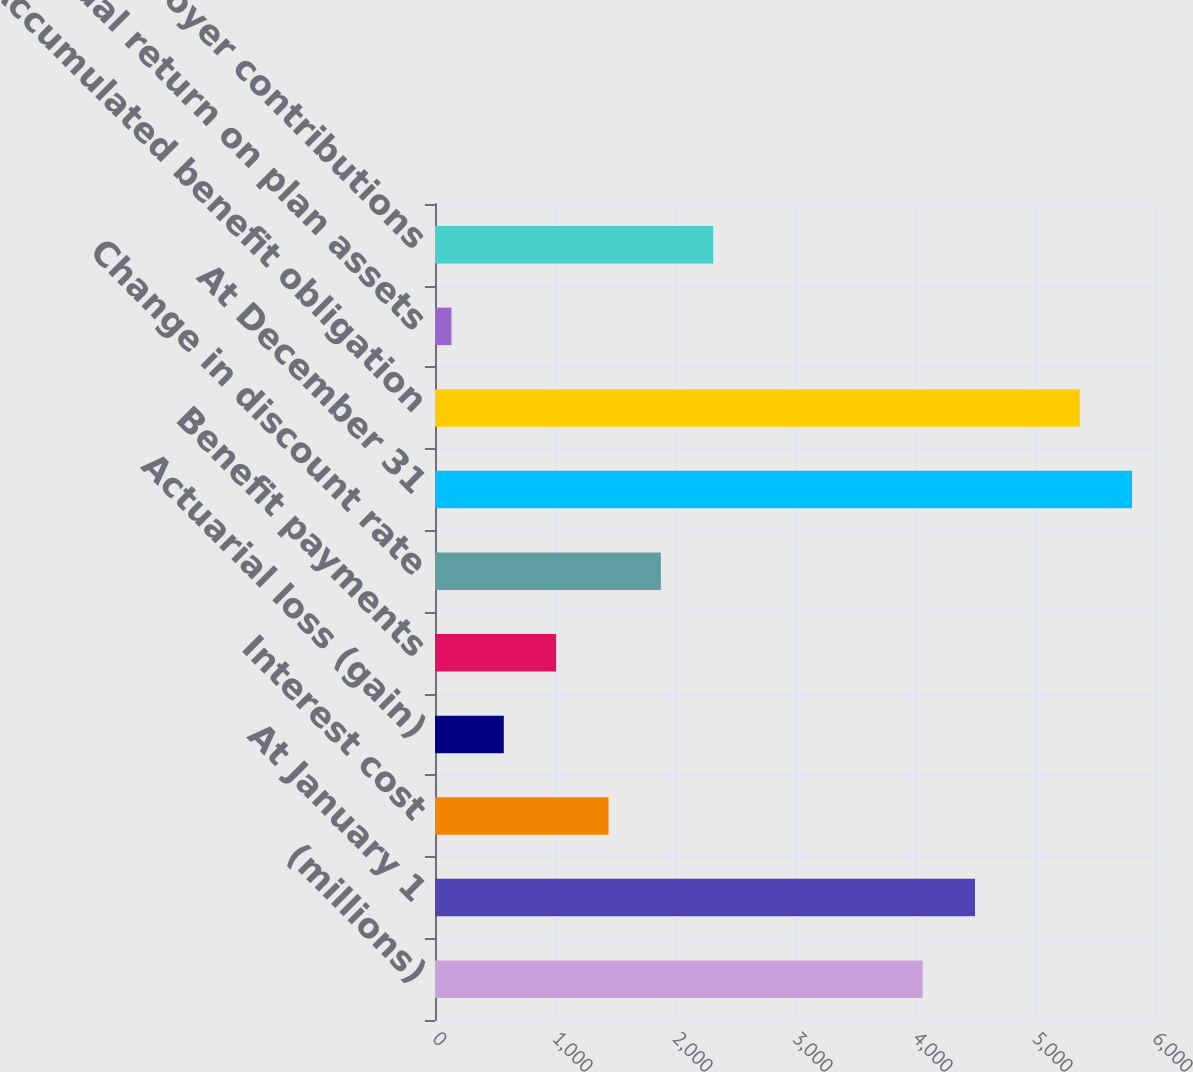<chart> <loc_0><loc_0><loc_500><loc_500><bar_chart><fcel>(millions)<fcel>At January 1<fcel>Interest cost<fcel>Actuarial loss (gain)<fcel>Benefit payments<fcel>Change in discount rate<fcel>At December 31<fcel>Accumulated benefit obligation<fcel>Actual return on plan assets<fcel>Employer contributions<nl><fcel>4063.7<fcel>4500<fcel>1445.9<fcel>573.3<fcel>1009.6<fcel>1882.2<fcel>5808.9<fcel>5372.6<fcel>137<fcel>2318.5<nl></chart> 